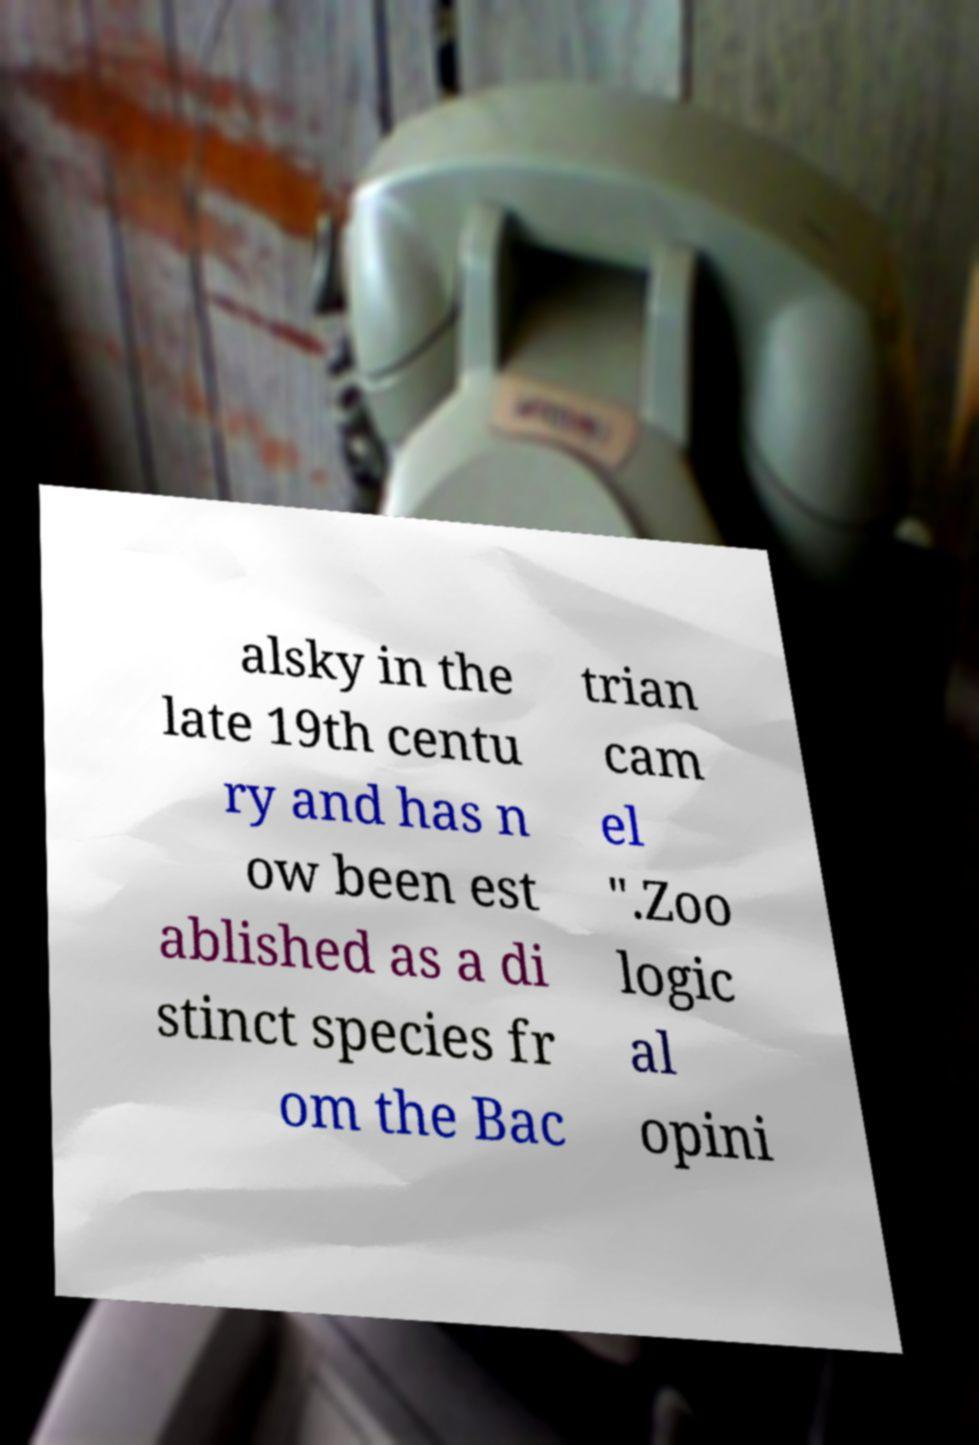I need the written content from this picture converted into text. Can you do that? alsky in the late 19th centu ry and has n ow been est ablished as a di stinct species fr om the Bac trian cam el ".Zoo logic al opini 